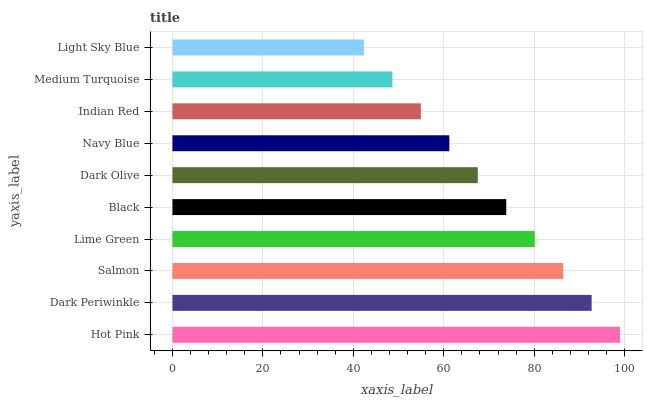Is Light Sky Blue the minimum?
Answer yes or no. Yes. Is Hot Pink the maximum?
Answer yes or no. Yes. Is Dark Periwinkle the minimum?
Answer yes or no. No. Is Dark Periwinkle the maximum?
Answer yes or no. No. Is Hot Pink greater than Dark Periwinkle?
Answer yes or no. Yes. Is Dark Periwinkle less than Hot Pink?
Answer yes or no. Yes. Is Dark Periwinkle greater than Hot Pink?
Answer yes or no. No. Is Hot Pink less than Dark Periwinkle?
Answer yes or no. No. Is Black the high median?
Answer yes or no. Yes. Is Dark Olive the low median?
Answer yes or no. Yes. Is Navy Blue the high median?
Answer yes or no. No. Is Lime Green the low median?
Answer yes or no. No. 